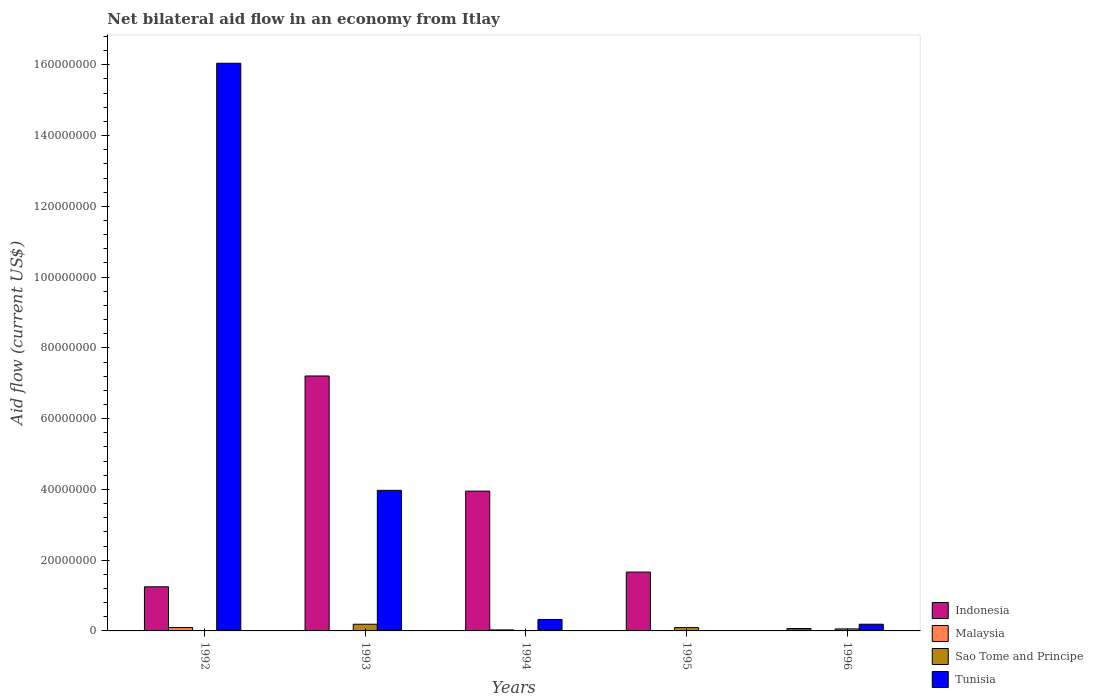How many different coloured bars are there?
Offer a terse response. 4. How many groups of bars are there?
Offer a very short reply. 5. In how many cases, is the number of bars for a given year not equal to the number of legend labels?
Ensure brevity in your answer.  1. What is the net bilateral aid flow in Sao Tome and Principe in 1992?
Ensure brevity in your answer.  10000. Across all years, what is the maximum net bilateral aid flow in Malaysia?
Your answer should be very brief. 9.60e+05. What is the total net bilateral aid flow in Indonesia in the graph?
Give a very brief answer. 1.41e+08. What is the difference between the net bilateral aid flow in Indonesia in 1992 and that in 1994?
Keep it short and to the point. -2.70e+07. What is the average net bilateral aid flow in Malaysia per year?
Keep it short and to the point. 2.82e+05. In the year 1992, what is the difference between the net bilateral aid flow in Tunisia and net bilateral aid flow in Indonesia?
Keep it short and to the point. 1.48e+08. What is the ratio of the net bilateral aid flow in Indonesia in 1992 to that in 1995?
Your answer should be compact. 0.75. Is the net bilateral aid flow in Tunisia in 1992 less than that in 1996?
Your answer should be very brief. No. Is the difference between the net bilateral aid flow in Tunisia in 1993 and 1996 greater than the difference between the net bilateral aid flow in Indonesia in 1993 and 1996?
Give a very brief answer. No. What is the difference between the highest and the second highest net bilateral aid flow in Malaysia?
Give a very brief answer. 6.70e+05. What is the difference between the highest and the lowest net bilateral aid flow in Sao Tome and Principe?
Make the answer very short. 1.88e+06. Is the sum of the net bilateral aid flow in Malaysia in 1994 and 1995 greater than the maximum net bilateral aid flow in Indonesia across all years?
Your answer should be very brief. No. Is it the case that in every year, the sum of the net bilateral aid flow in Indonesia and net bilateral aid flow in Sao Tome and Principe is greater than the sum of net bilateral aid flow in Malaysia and net bilateral aid flow in Tunisia?
Provide a short and direct response. No. Is it the case that in every year, the sum of the net bilateral aid flow in Malaysia and net bilateral aid flow in Indonesia is greater than the net bilateral aid flow in Sao Tome and Principe?
Your answer should be very brief. Yes. How many years are there in the graph?
Your answer should be very brief. 5. What is the difference between two consecutive major ticks on the Y-axis?
Provide a short and direct response. 2.00e+07. Are the values on the major ticks of Y-axis written in scientific E-notation?
Your answer should be compact. No. Does the graph contain any zero values?
Ensure brevity in your answer.  Yes. Where does the legend appear in the graph?
Make the answer very short. Bottom right. How many legend labels are there?
Keep it short and to the point. 4. How are the legend labels stacked?
Provide a short and direct response. Vertical. What is the title of the graph?
Make the answer very short. Net bilateral aid flow in an economy from Itlay. Does "Syrian Arab Republic" appear as one of the legend labels in the graph?
Offer a very short reply. No. What is the label or title of the X-axis?
Your response must be concise. Years. What is the Aid flow (current US$) in Indonesia in 1992?
Your answer should be compact. 1.25e+07. What is the Aid flow (current US$) of Malaysia in 1992?
Your response must be concise. 9.60e+05. What is the Aid flow (current US$) in Tunisia in 1992?
Offer a terse response. 1.60e+08. What is the Aid flow (current US$) of Indonesia in 1993?
Offer a very short reply. 7.20e+07. What is the Aid flow (current US$) in Malaysia in 1993?
Ensure brevity in your answer.  5.00e+04. What is the Aid flow (current US$) in Sao Tome and Principe in 1993?
Your answer should be very brief. 1.89e+06. What is the Aid flow (current US$) in Tunisia in 1993?
Keep it short and to the point. 3.97e+07. What is the Aid flow (current US$) of Indonesia in 1994?
Ensure brevity in your answer.  3.95e+07. What is the Aid flow (current US$) of Tunisia in 1994?
Your answer should be very brief. 3.24e+06. What is the Aid flow (current US$) in Indonesia in 1995?
Offer a very short reply. 1.66e+07. What is the Aid flow (current US$) of Malaysia in 1995?
Give a very brief answer. 8.00e+04. What is the Aid flow (current US$) of Sao Tome and Principe in 1995?
Your response must be concise. 9.40e+05. What is the Aid flow (current US$) of Tunisia in 1995?
Provide a succinct answer. 0. What is the Aid flow (current US$) in Indonesia in 1996?
Make the answer very short. 6.70e+05. What is the Aid flow (current US$) of Malaysia in 1996?
Keep it short and to the point. 3.00e+04. What is the Aid flow (current US$) in Sao Tome and Principe in 1996?
Your response must be concise. 5.70e+05. What is the Aid flow (current US$) in Tunisia in 1996?
Your answer should be compact. 1.89e+06. Across all years, what is the maximum Aid flow (current US$) of Indonesia?
Keep it short and to the point. 7.20e+07. Across all years, what is the maximum Aid flow (current US$) of Malaysia?
Offer a terse response. 9.60e+05. Across all years, what is the maximum Aid flow (current US$) in Sao Tome and Principe?
Your answer should be very brief. 1.89e+06. Across all years, what is the maximum Aid flow (current US$) of Tunisia?
Your answer should be very brief. 1.60e+08. Across all years, what is the minimum Aid flow (current US$) of Indonesia?
Make the answer very short. 6.70e+05. Across all years, what is the minimum Aid flow (current US$) in Malaysia?
Give a very brief answer. 3.00e+04. What is the total Aid flow (current US$) in Indonesia in the graph?
Keep it short and to the point. 1.41e+08. What is the total Aid flow (current US$) in Malaysia in the graph?
Offer a terse response. 1.41e+06. What is the total Aid flow (current US$) of Sao Tome and Principe in the graph?
Make the answer very short. 3.42e+06. What is the total Aid flow (current US$) in Tunisia in the graph?
Offer a very short reply. 2.05e+08. What is the difference between the Aid flow (current US$) of Indonesia in 1992 and that in 1993?
Ensure brevity in your answer.  -5.96e+07. What is the difference between the Aid flow (current US$) of Malaysia in 1992 and that in 1993?
Keep it short and to the point. 9.10e+05. What is the difference between the Aid flow (current US$) in Sao Tome and Principe in 1992 and that in 1993?
Make the answer very short. -1.88e+06. What is the difference between the Aid flow (current US$) of Tunisia in 1992 and that in 1993?
Offer a very short reply. 1.21e+08. What is the difference between the Aid flow (current US$) in Indonesia in 1992 and that in 1994?
Make the answer very short. -2.70e+07. What is the difference between the Aid flow (current US$) of Malaysia in 1992 and that in 1994?
Your answer should be very brief. 6.70e+05. What is the difference between the Aid flow (current US$) of Tunisia in 1992 and that in 1994?
Ensure brevity in your answer.  1.57e+08. What is the difference between the Aid flow (current US$) of Indonesia in 1992 and that in 1995?
Ensure brevity in your answer.  -4.16e+06. What is the difference between the Aid flow (current US$) of Malaysia in 1992 and that in 1995?
Keep it short and to the point. 8.80e+05. What is the difference between the Aid flow (current US$) of Sao Tome and Principe in 1992 and that in 1995?
Your answer should be compact. -9.30e+05. What is the difference between the Aid flow (current US$) in Indonesia in 1992 and that in 1996?
Make the answer very short. 1.18e+07. What is the difference between the Aid flow (current US$) in Malaysia in 1992 and that in 1996?
Keep it short and to the point. 9.30e+05. What is the difference between the Aid flow (current US$) in Sao Tome and Principe in 1992 and that in 1996?
Give a very brief answer. -5.60e+05. What is the difference between the Aid flow (current US$) in Tunisia in 1992 and that in 1996?
Ensure brevity in your answer.  1.59e+08. What is the difference between the Aid flow (current US$) in Indonesia in 1993 and that in 1994?
Your answer should be compact. 3.25e+07. What is the difference between the Aid flow (current US$) of Malaysia in 1993 and that in 1994?
Ensure brevity in your answer.  -2.40e+05. What is the difference between the Aid flow (current US$) in Sao Tome and Principe in 1993 and that in 1994?
Your answer should be very brief. 1.88e+06. What is the difference between the Aid flow (current US$) in Tunisia in 1993 and that in 1994?
Ensure brevity in your answer.  3.65e+07. What is the difference between the Aid flow (current US$) of Indonesia in 1993 and that in 1995?
Your response must be concise. 5.54e+07. What is the difference between the Aid flow (current US$) of Malaysia in 1993 and that in 1995?
Ensure brevity in your answer.  -3.00e+04. What is the difference between the Aid flow (current US$) in Sao Tome and Principe in 1993 and that in 1995?
Offer a terse response. 9.50e+05. What is the difference between the Aid flow (current US$) in Indonesia in 1993 and that in 1996?
Give a very brief answer. 7.14e+07. What is the difference between the Aid flow (current US$) of Malaysia in 1993 and that in 1996?
Offer a terse response. 2.00e+04. What is the difference between the Aid flow (current US$) of Sao Tome and Principe in 1993 and that in 1996?
Ensure brevity in your answer.  1.32e+06. What is the difference between the Aid flow (current US$) in Tunisia in 1993 and that in 1996?
Ensure brevity in your answer.  3.78e+07. What is the difference between the Aid flow (current US$) of Indonesia in 1994 and that in 1995?
Provide a short and direct response. 2.29e+07. What is the difference between the Aid flow (current US$) in Sao Tome and Principe in 1994 and that in 1995?
Give a very brief answer. -9.30e+05. What is the difference between the Aid flow (current US$) of Indonesia in 1994 and that in 1996?
Your response must be concise. 3.88e+07. What is the difference between the Aid flow (current US$) of Malaysia in 1994 and that in 1996?
Provide a short and direct response. 2.60e+05. What is the difference between the Aid flow (current US$) in Sao Tome and Principe in 1994 and that in 1996?
Offer a very short reply. -5.60e+05. What is the difference between the Aid flow (current US$) of Tunisia in 1994 and that in 1996?
Your answer should be compact. 1.35e+06. What is the difference between the Aid flow (current US$) of Indonesia in 1995 and that in 1996?
Offer a terse response. 1.60e+07. What is the difference between the Aid flow (current US$) of Indonesia in 1992 and the Aid flow (current US$) of Malaysia in 1993?
Give a very brief answer. 1.24e+07. What is the difference between the Aid flow (current US$) of Indonesia in 1992 and the Aid flow (current US$) of Sao Tome and Principe in 1993?
Give a very brief answer. 1.06e+07. What is the difference between the Aid flow (current US$) of Indonesia in 1992 and the Aid flow (current US$) of Tunisia in 1993?
Ensure brevity in your answer.  -2.73e+07. What is the difference between the Aid flow (current US$) in Malaysia in 1992 and the Aid flow (current US$) in Sao Tome and Principe in 1993?
Make the answer very short. -9.30e+05. What is the difference between the Aid flow (current US$) in Malaysia in 1992 and the Aid flow (current US$) in Tunisia in 1993?
Provide a short and direct response. -3.88e+07. What is the difference between the Aid flow (current US$) of Sao Tome and Principe in 1992 and the Aid flow (current US$) of Tunisia in 1993?
Ensure brevity in your answer.  -3.97e+07. What is the difference between the Aid flow (current US$) of Indonesia in 1992 and the Aid flow (current US$) of Malaysia in 1994?
Offer a terse response. 1.22e+07. What is the difference between the Aid flow (current US$) in Indonesia in 1992 and the Aid flow (current US$) in Sao Tome and Principe in 1994?
Your answer should be compact. 1.25e+07. What is the difference between the Aid flow (current US$) of Indonesia in 1992 and the Aid flow (current US$) of Tunisia in 1994?
Keep it short and to the point. 9.23e+06. What is the difference between the Aid flow (current US$) in Malaysia in 1992 and the Aid flow (current US$) in Sao Tome and Principe in 1994?
Offer a terse response. 9.50e+05. What is the difference between the Aid flow (current US$) of Malaysia in 1992 and the Aid flow (current US$) of Tunisia in 1994?
Keep it short and to the point. -2.28e+06. What is the difference between the Aid flow (current US$) in Sao Tome and Principe in 1992 and the Aid flow (current US$) in Tunisia in 1994?
Your answer should be compact. -3.23e+06. What is the difference between the Aid flow (current US$) in Indonesia in 1992 and the Aid flow (current US$) in Malaysia in 1995?
Your answer should be very brief. 1.24e+07. What is the difference between the Aid flow (current US$) in Indonesia in 1992 and the Aid flow (current US$) in Sao Tome and Principe in 1995?
Your answer should be very brief. 1.15e+07. What is the difference between the Aid flow (current US$) in Indonesia in 1992 and the Aid flow (current US$) in Malaysia in 1996?
Provide a short and direct response. 1.24e+07. What is the difference between the Aid flow (current US$) in Indonesia in 1992 and the Aid flow (current US$) in Sao Tome and Principe in 1996?
Your answer should be compact. 1.19e+07. What is the difference between the Aid flow (current US$) in Indonesia in 1992 and the Aid flow (current US$) in Tunisia in 1996?
Offer a very short reply. 1.06e+07. What is the difference between the Aid flow (current US$) in Malaysia in 1992 and the Aid flow (current US$) in Tunisia in 1996?
Make the answer very short. -9.30e+05. What is the difference between the Aid flow (current US$) in Sao Tome and Principe in 1992 and the Aid flow (current US$) in Tunisia in 1996?
Keep it short and to the point. -1.88e+06. What is the difference between the Aid flow (current US$) of Indonesia in 1993 and the Aid flow (current US$) of Malaysia in 1994?
Offer a terse response. 7.18e+07. What is the difference between the Aid flow (current US$) of Indonesia in 1993 and the Aid flow (current US$) of Sao Tome and Principe in 1994?
Your response must be concise. 7.20e+07. What is the difference between the Aid flow (current US$) in Indonesia in 1993 and the Aid flow (current US$) in Tunisia in 1994?
Provide a short and direct response. 6.88e+07. What is the difference between the Aid flow (current US$) in Malaysia in 1993 and the Aid flow (current US$) in Sao Tome and Principe in 1994?
Give a very brief answer. 4.00e+04. What is the difference between the Aid flow (current US$) of Malaysia in 1993 and the Aid flow (current US$) of Tunisia in 1994?
Your answer should be very brief. -3.19e+06. What is the difference between the Aid flow (current US$) of Sao Tome and Principe in 1993 and the Aid flow (current US$) of Tunisia in 1994?
Ensure brevity in your answer.  -1.35e+06. What is the difference between the Aid flow (current US$) of Indonesia in 1993 and the Aid flow (current US$) of Malaysia in 1995?
Make the answer very short. 7.20e+07. What is the difference between the Aid flow (current US$) in Indonesia in 1993 and the Aid flow (current US$) in Sao Tome and Principe in 1995?
Your answer should be compact. 7.11e+07. What is the difference between the Aid flow (current US$) of Malaysia in 1993 and the Aid flow (current US$) of Sao Tome and Principe in 1995?
Ensure brevity in your answer.  -8.90e+05. What is the difference between the Aid flow (current US$) of Indonesia in 1993 and the Aid flow (current US$) of Malaysia in 1996?
Give a very brief answer. 7.20e+07. What is the difference between the Aid flow (current US$) of Indonesia in 1993 and the Aid flow (current US$) of Sao Tome and Principe in 1996?
Your answer should be compact. 7.15e+07. What is the difference between the Aid flow (current US$) in Indonesia in 1993 and the Aid flow (current US$) in Tunisia in 1996?
Keep it short and to the point. 7.02e+07. What is the difference between the Aid flow (current US$) in Malaysia in 1993 and the Aid flow (current US$) in Sao Tome and Principe in 1996?
Provide a succinct answer. -5.20e+05. What is the difference between the Aid flow (current US$) of Malaysia in 1993 and the Aid flow (current US$) of Tunisia in 1996?
Give a very brief answer. -1.84e+06. What is the difference between the Aid flow (current US$) in Sao Tome and Principe in 1993 and the Aid flow (current US$) in Tunisia in 1996?
Your answer should be compact. 0. What is the difference between the Aid flow (current US$) of Indonesia in 1994 and the Aid flow (current US$) of Malaysia in 1995?
Provide a succinct answer. 3.94e+07. What is the difference between the Aid flow (current US$) in Indonesia in 1994 and the Aid flow (current US$) in Sao Tome and Principe in 1995?
Give a very brief answer. 3.86e+07. What is the difference between the Aid flow (current US$) in Malaysia in 1994 and the Aid flow (current US$) in Sao Tome and Principe in 1995?
Your answer should be compact. -6.50e+05. What is the difference between the Aid flow (current US$) in Indonesia in 1994 and the Aid flow (current US$) in Malaysia in 1996?
Offer a terse response. 3.95e+07. What is the difference between the Aid flow (current US$) of Indonesia in 1994 and the Aid flow (current US$) of Sao Tome and Principe in 1996?
Your response must be concise. 3.89e+07. What is the difference between the Aid flow (current US$) in Indonesia in 1994 and the Aid flow (current US$) in Tunisia in 1996?
Your answer should be very brief. 3.76e+07. What is the difference between the Aid flow (current US$) of Malaysia in 1994 and the Aid flow (current US$) of Sao Tome and Principe in 1996?
Offer a terse response. -2.80e+05. What is the difference between the Aid flow (current US$) of Malaysia in 1994 and the Aid flow (current US$) of Tunisia in 1996?
Your answer should be very brief. -1.60e+06. What is the difference between the Aid flow (current US$) of Sao Tome and Principe in 1994 and the Aid flow (current US$) of Tunisia in 1996?
Provide a succinct answer. -1.88e+06. What is the difference between the Aid flow (current US$) in Indonesia in 1995 and the Aid flow (current US$) in Malaysia in 1996?
Provide a short and direct response. 1.66e+07. What is the difference between the Aid flow (current US$) in Indonesia in 1995 and the Aid flow (current US$) in Sao Tome and Principe in 1996?
Offer a terse response. 1.61e+07. What is the difference between the Aid flow (current US$) of Indonesia in 1995 and the Aid flow (current US$) of Tunisia in 1996?
Provide a succinct answer. 1.47e+07. What is the difference between the Aid flow (current US$) of Malaysia in 1995 and the Aid flow (current US$) of Sao Tome and Principe in 1996?
Provide a succinct answer. -4.90e+05. What is the difference between the Aid flow (current US$) of Malaysia in 1995 and the Aid flow (current US$) of Tunisia in 1996?
Offer a very short reply. -1.81e+06. What is the difference between the Aid flow (current US$) of Sao Tome and Principe in 1995 and the Aid flow (current US$) of Tunisia in 1996?
Ensure brevity in your answer.  -9.50e+05. What is the average Aid flow (current US$) of Indonesia per year?
Your response must be concise. 2.83e+07. What is the average Aid flow (current US$) in Malaysia per year?
Provide a succinct answer. 2.82e+05. What is the average Aid flow (current US$) of Sao Tome and Principe per year?
Provide a short and direct response. 6.84e+05. What is the average Aid flow (current US$) in Tunisia per year?
Your response must be concise. 4.11e+07. In the year 1992, what is the difference between the Aid flow (current US$) in Indonesia and Aid flow (current US$) in Malaysia?
Provide a succinct answer. 1.15e+07. In the year 1992, what is the difference between the Aid flow (current US$) in Indonesia and Aid flow (current US$) in Sao Tome and Principe?
Make the answer very short. 1.25e+07. In the year 1992, what is the difference between the Aid flow (current US$) in Indonesia and Aid flow (current US$) in Tunisia?
Keep it short and to the point. -1.48e+08. In the year 1992, what is the difference between the Aid flow (current US$) of Malaysia and Aid flow (current US$) of Sao Tome and Principe?
Make the answer very short. 9.50e+05. In the year 1992, what is the difference between the Aid flow (current US$) in Malaysia and Aid flow (current US$) in Tunisia?
Your answer should be very brief. -1.59e+08. In the year 1992, what is the difference between the Aid flow (current US$) of Sao Tome and Principe and Aid flow (current US$) of Tunisia?
Offer a very short reply. -1.60e+08. In the year 1993, what is the difference between the Aid flow (current US$) in Indonesia and Aid flow (current US$) in Malaysia?
Give a very brief answer. 7.20e+07. In the year 1993, what is the difference between the Aid flow (current US$) in Indonesia and Aid flow (current US$) in Sao Tome and Principe?
Give a very brief answer. 7.02e+07. In the year 1993, what is the difference between the Aid flow (current US$) of Indonesia and Aid flow (current US$) of Tunisia?
Your response must be concise. 3.23e+07. In the year 1993, what is the difference between the Aid flow (current US$) of Malaysia and Aid flow (current US$) of Sao Tome and Principe?
Provide a succinct answer. -1.84e+06. In the year 1993, what is the difference between the Aid flow (current US$) of Malaysia and Aid flow (current US$) of Tunisia?
Make the answer very short. -3.97e+07. In the year 1993, what is the difference between the Aid flow (current US$) in Sao Tome and Principe and Aid flow (current US$) in Tunisia?
Offer a very short reply. -3.78e+07. In the year 1994, what is the difference between the Aid flow (current US$) in Indonesia and Aid flow (current US$) in Malaysia?
Make the answer very short. 3.92e+07. In the year 1994, what is the difference between the Aid flow (current US$) of Indonesia and Aid flow (current US$) of Sao Tome and Principe?
Provide a short and direct response. 3.95e+07. In the year 1994, what is the difference between the Aid flow (current US$) of Indonesia and Aid flow (current US$) of Tunisia?
Provide a short and direct response. 3.63e+07. In the year 1994, what is the difference between the Aid flow (current US$) of Malaysia and Aid flow (current US$) of Sao Tome and Principe?
Your response must be concise. 2.80e+05. In the year 1994, what is the difference between the Aid flow (current US$) in Malaysia and Aid flow (current US$) in Tunisia?
Your response must be concise. -2.95e+06. In the year 1994, what is the difference between the Aid flow (current US$) in Sao Tome and Principe and Aid flow (current US$) in Tunisia?
Keep it short and to the point. -3.23e+06. In the year 1995, what is the difference between the Aid flow (current US$) in Indonesia and Aid flow (current US$) in Malaysia?
Your answer should be very brief. 1.66e+07. In the year 1995, what is the difference between the Aid flow (current US$) in Indonesia and Aid flow (current US$) in Sao Tome and Principe?
Give a very brief answer. 1.57e+07. In the year 1995, what is the difference between the Aid flow (current US$) in Malaysia and Aid flow (current US$) in Sao Tome and Principe?
Your answer should be very brief. -8.60e+05. In the year 1996, what is the difference between the Aid flow (current US$) in Indonesia and Aid flow (current US$) in Malaysia?
Keep it short and to the point. 6.40e+05. In the year 1996, what is the difference between the Aid flow (current US$) of Indonesia and Aid flow (current US$) of Tunisia?
Offer a terse response. -1.22e+06. In the year 1996, what is the difference between the Aid flow (current US$) in Malaysia and Aid flow (current US$) in Sao Tome and Principe?
Your answer should be compact. -5.40e+05. In the year 1996, what is the difference between the Aid flow (current US$) in Malaysia and Aid flow (current US$) in Tunisia?
Give a very brief answer. -1.86e+06. In the year 1996, what is the difference between the Aid flow (current US$) in Sao Tome and Principe and Aid flow (current US$) in Tunisia?
Offer a very short reply. -1.32e+06. What is the ratio of the Aid flow (current US$) in Indonesia in 1992 to that in 1993?
Your answer should be compact. 0.17. What is the ratio of the Aid flow (current US$) of Malaysia in 1992 to that in 1993?
Ensure brevity in your answer.  19.2. What is the ratio of the Aid flow (current US$) in Sao Tome and Principe in 1992 to that in 1993?
Offer a terse response. 0.01. What is the ratio of the Aid flow (current US$) of Tunisia in 1992 to that in 1993?
Your answer should be compact. 4.04. What is the ratio of the Aid flow (current US$) of Indonesia in 1992 to that in 1994?
Ensure brevity in your answer.  0.32. What is the ratio of the Aid flow (current US$) in Malaysia in 1992 to that in 1994?
Provide a short and direct response. 3.31. What is the ratio of the Aid flow (current US$) of Sao Tome and Principe in 1992 to that in 1994?
Your response must be concise. 1. What is the ratio of the Aid flow (current US$) in Tunisia in 1992 to that in 1994?
Make the answer very short. 49.52. What is the ratio of the Aid flow (current US$) of Indonesia in 1992 to that in 1995?
Provide a short and direct response. 0.75. What is the ratio of the Aid flow (current US$) of Sao Tome and Principe in 1992 to that in 1995?
Make the answer very short. 0.01. What is the ratio of the Aid flow (current US$) of Indonesia in 1992 to that in 1996?
Give a very brief answer. 18.61. What is the ratio of the Aid flow (current US$) of Sao Tome and Principe in 1992 to that in 1996?
Make the answer very short. 0.02. What is the ratio of the Aid flow (current US$) in Tunisia in 1992 to that in 1996?
Your answer should be very brief. 84.88. What is the ratio of the Aid flow (current US$) of Indonesia in 1993 to that in 1994?
Offer a terse response. 1.82. What is the ratio of the Aid flow (current US$) of Malaysia in 1993 to that in 1994?
Offer a terse response. 0.17. What is the ratio of the Aid flow (current US$) in Sao Tome and Principe in 1993 to that in 1994?
Your answer should be compact. 189. What is the ratio of the Aid flow (current US$) in Tunisia in 1993 to that in 1994?
Offer a terse response. 12.26. What is the ratio of the Aid flow (current US$) of Indonesia in 1993 to that in 1995?
Offer a terse response. 4.33. What is the ratio of the Aid flow (current US$) in Malaysia in 1993 to that in 1995?
Your response must be concise. 0.62. What is the ratio of the Aid flow (current US$) in Sao Tome and Principe in 1993 to that in 1995?
Offer a very short reply. 2.01. What is the ratio of the Aid flow (current US$) in Indonesia in 1993 to that in 1996?
Your answer should be compact. 107.54. What is the ratio of the Aid flow (current US$) in Malaysia in 1993 to that in 1996?
Your answer should be compact. 1.67. What is the ratio of the Aid flow (current US$) of Sao Tome and Principe in 1993 to that in 1996?
Keep it short and to the point. 3.32. What is the ratio of the Aid flow (current US$) of Tunisia in 1993 to that in 1996?
Offer a terse response. 21.02. What is the ratio of the Aid flow (current US$) in Indonesia in 1994 to that in 1995?
Keep it short and to the point. 2.38. What is the ratio of the Aid flow (current US$) in Malaysia in 1994 to that in 1995?
Keep it short and to the point. 3.62. What is the ratio of the Aid flow (current US$) in Sao Tome and Principe in 1994 to that in 1995?
Provide a short and direct response. 0.01. What is the ratio of the Aid flow (current US$) in Indonesia in 1994 to that in 1996?
Keep it short and to the point. 58.97. What is the ratio of the Aid flow (current US$) in Malaysia in 1994 to that in 1996?
Provide a succinct answer. 9.67. What is the ratio of the Aid flow (current US$) in Sao Tome and Principe in 1994 to that in 1996?
Your answer should be compact. 0.02. What is the ratio of the Aid flow (current US$) of Tunisia in 1994 to that in 1996?
Your answer should be very brief. 1.71. What is the ratio of the Aid flow (current US$) in Indonesia in 1995 to that in 1996?
Provide a succinct answer. 24.82. What is the ratio of the Aid flow (current US$) in Malaysia in 1995 to that in 1996?
Provide a short and direct response. 2.67. What is the ratio of the Aid flow (current US$) in Sao Tome and Principe in 1995 to that in 1996?
Keep it short and to the point. 1.65. What is the difference between the highest and the second highest Aid flow (current US$) of Indonesia?
Your answer should be very brief. 3.25e+07. What is the difference between the highest and the second highest Aid flow (current US$) of Malaysia?
Offer a terse response. 6.70e+05. What is the difference between the highest and the second highest Aid flow (current US$) of Sao Tome and Principe?
Provide a short and direct response. 9.50e+05. What is the difference between the highest and the second highest Aid flow (current US$) of Tunisia?
Keep it short and to the point. 1.21e+08. What is the difference between the highest and the lowest Aid flow (current US$) in Indonesia?
Your answer should be very brief. 7.14e+07. What is the difference between the highest and the lowest Aid flow (current US$) of Malaysia?
Make the answer very short. 9.30e+05. What is the difference between the highest and the lowest Aid flow (current US$) of Sao Tome and Principe?
Your answer should be very brief. 1.88e+06. What is the difference between the highest and the lowest Aid flow (current US$) in Tunisia?
Offer a very short reply. 1.60e+08. 